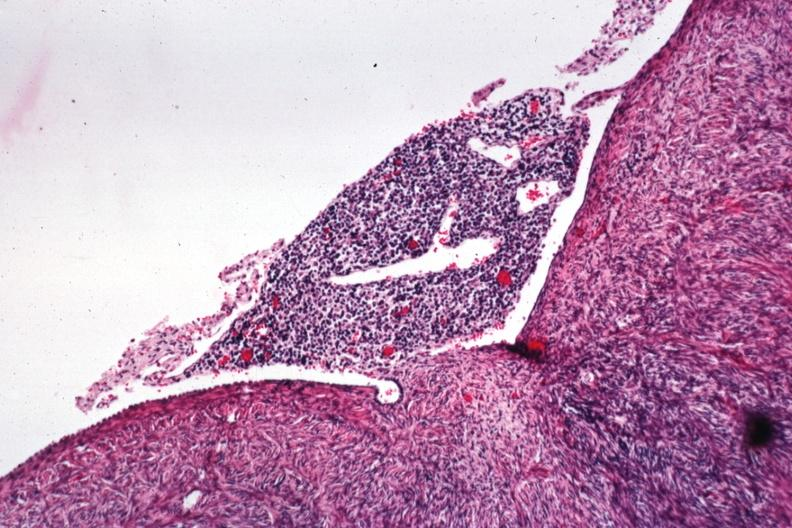s female reproductive present?
Answer the question using a single word or phrase. Yes 